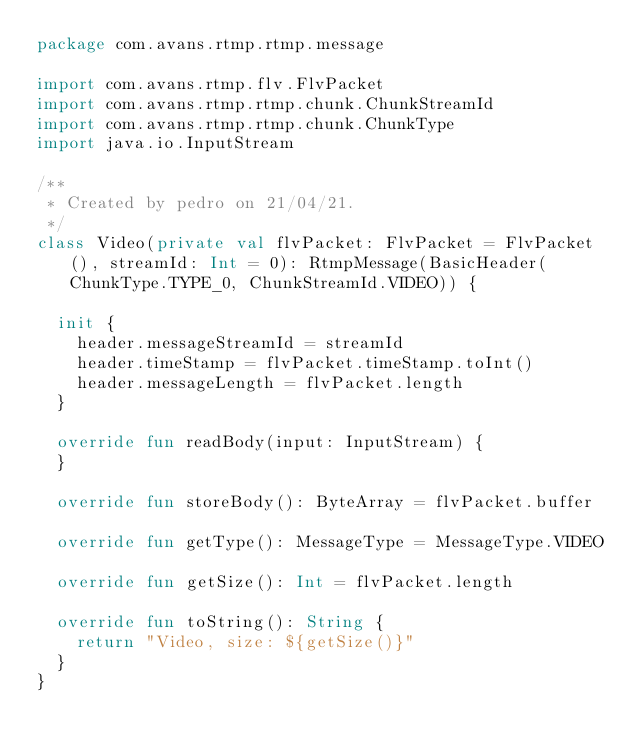Convert code to text. <code><loc_0><loc_0><loc_500><loc_500><_Kotlin_>package com.avans.rtmp.rtmp.message

import com.avans.rtmp.flv.FlvPacket
import com.avans.rtmp.rtmp.chunk.ChunkStreamId
import com.avans.rtmp.rtmp.chunk.ChunkType
import java.io.InputStream

/**
 * Created by pedro on 21/04/21.
 */
class Video(private val flvPacket: FlvPacket = FlvPacket(), streamId: Int = 0): RtmpMessage(BasicHeader(ChunkType.TYPE_0, ChunkStreamId.VIDEO)) {

  init {
    header.messageStreamId = streamId
    header.timeStamp = flvPacket.timeStamp.toInt()
    header.messageLength = flvPacket.length
  }

  override fun readBody(input: InputStream) {
  }

  override fun storeBody(): ByteArray = flvPacket.buffer

  override fun getType(): MessageType = MessageType.VIDEO

  override fun getSize(): Int = flvPacket.length

  override fun toString(): String {
    return "Video, size: ${getSize()}"
  }
}</code> 